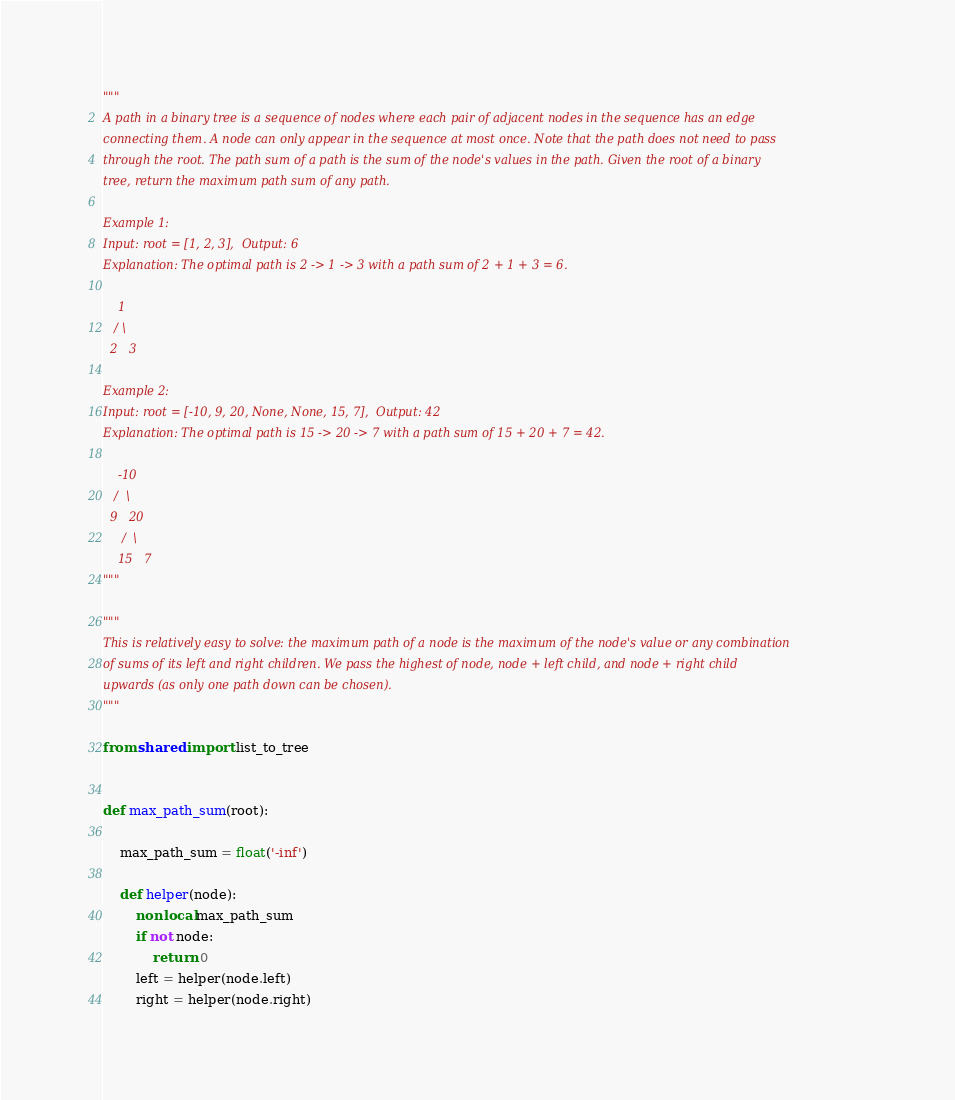<code> <loc_0><loc_0><loc_500><loc_500><_Python_>"""
A path in a binary tree is a sequence of nodes where each pair of adjacent nodes in the sequence has an edge
connecting them. A node can only appear in the sequence at most once. Note that the path does not need to pass
through the root. The path sum of a path is the sum of the node's values in the path. Given the root of a binary
tree, return the maximum path sum of any path.

Example 1:
Input: root = [1, 2, 3],  Output: 6
Explanation: The optimal path is 2 -> 1 -> 3 with a path sum of 2 + 1 + 3 = 6.

    1
   / \
  2   3

Example 2:
Input: root = [-10, 9, 20, None, None, 15, 7],  Output: 42
Explanation: The optimal path is 15 -> 20 -> 7 with a path sum of 15 + 20 + 7 = 42.

    -10
   /  \
  9   20
     /  \
    15   7
"""

"""
This is relatively easy to solve: the maximum path of a node is the maximum of the node's value or any combination
of sums of its left and right children. We pass the highest of node, node + left child, and node + right child
upwards (as only one path down can be chosen).
"""

from shared import list_to_tree


def max_path_sum(root):

    max_path_sum = float('-inf')

    def helper(node):
        nonlocal max_path_sum
        if not node:
            return 0
        left = helper(node.left)
        right = helper(node.right)</code> 